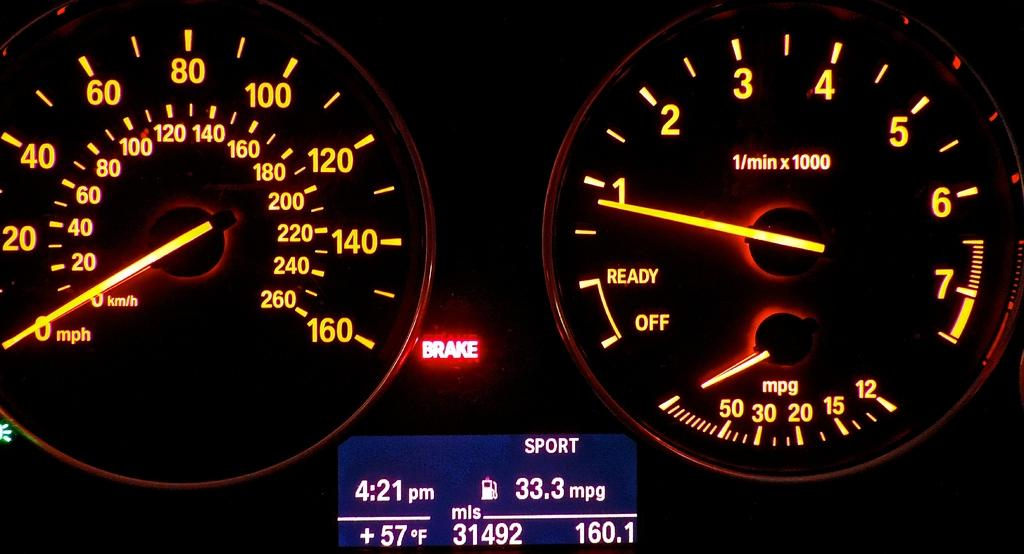Provide a one-sentence caption for the provided image. The speedometer and mpg gauges of a vehicle with the words Brake lighting up in red. 